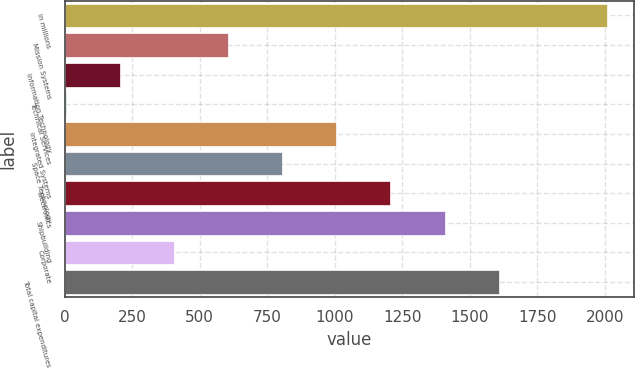Convert chart. <chart><loc_0><loc_0><loc_500><loc_500><bar_chart><fcel>in millions<fcel>Mission Systems<fcel>Information Technology<fcel>Technical Services<fcel>Integrated Systems<fcel>Space Technology<fcel>Electronics<fcel>Shipbuilding<fcel>Corporate<fcel>Total capital expenditures<nl><fcel>2008<fcel>604.5<fcel>203.5<fcel>3<fcel>1005.5<fcel>805<fcel>1206<fcel>1406.5<fcel>404<fcel>1607<nl></chart> 